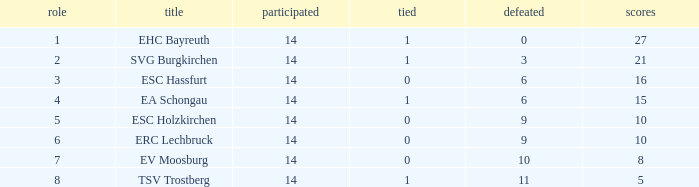Could you help me parse every detail presented in this table? {'header': ['role', 'title', 'participated', 'tied', 'defeated', 'scores'], 'rows': [['1', 'EHC Bayreuth', '14', '1', '0', '27'], ['2', 'SVG Burgkirchen', '14', '1', '3', '21'], ['3', 'ESC Hassfurt', '14', '0', '6', '16'], ['4', 'EA Schongau', '14', '1', '6', '15'], ['5', 'ESC Holzkirchen', '14', '0', '9', '10'], ['6', 'ERC Lechbruck', '14', '0', '9', '10'], ['7', 'EV Moosburg', '14', '0', '10', '8'], ['8', 'TSV Trostberg', '14', '1', '11', '5']]} What's the most points for Ea Schongau with more than 1 drawn? None. 